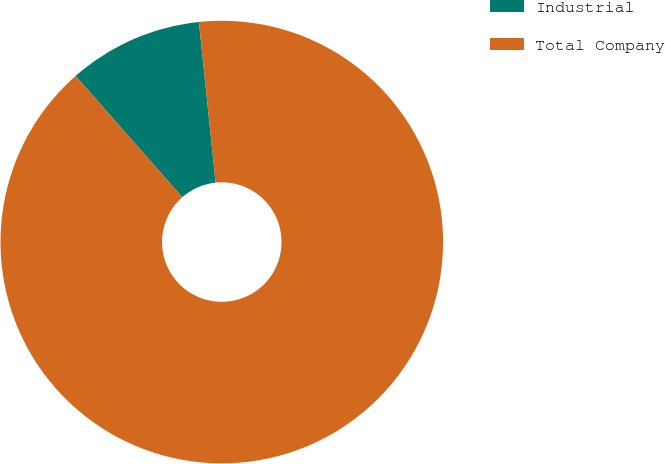Convert chart to OTSL. <chart><loc_0><loc_0><loc_500><loc_500><pie_chart><fcel>Industrial<fcel>Total Company<nl><fcel>9.84%<fcel>90.16%<nl></chart> 